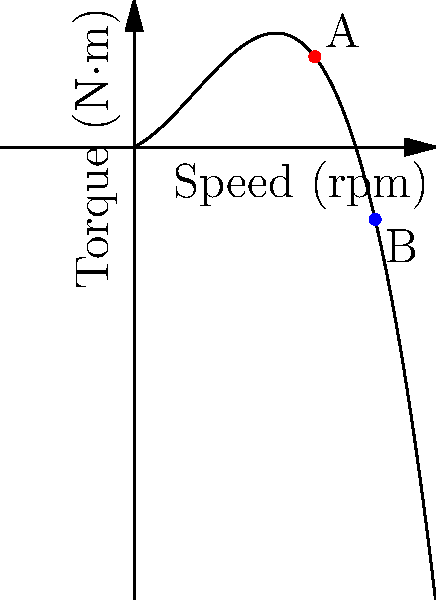The torque-speed characteristic of a damper winding in an electric motor is represented by the polynomial function $T(s) = -0.0005s^3 + 0.03s^2 + 0.5s$, where $T$ is the torque in N·m and $s$ is the speed in rpm. If the motor's speed increases from 60 rpm (point A) to 80 rpm (point B), what is the change in torque? To find the change in torque, we need to:

1. Calculate the torque at 60 rpm (point A):
   $T(60) = -0.0005(60)^3 + 0.03(60)^2 + 0.5(60)$
   $= -0.0005(216000) + 0.03(3600) + 30$
   $= -108 + 108 + 30 = 30$ N·m

2. Calculate the torque at 80 rpm (point B):
   $T(80) = -0.0005(80)^3 + 0.03(80)^2 + 0.5(80)$
   $= -0.0005(512000) + 0.03(6400) + 40$
   $= -256 + 192 + 40 = -24$ N·m

3. Calculate the change in torque:
   Change in torque = $T(80) - T(60) = -24 - 30 = -54$ N·m

The negative value indicates a decrease in torque as the speed increases.
Answer: -54 N·m 